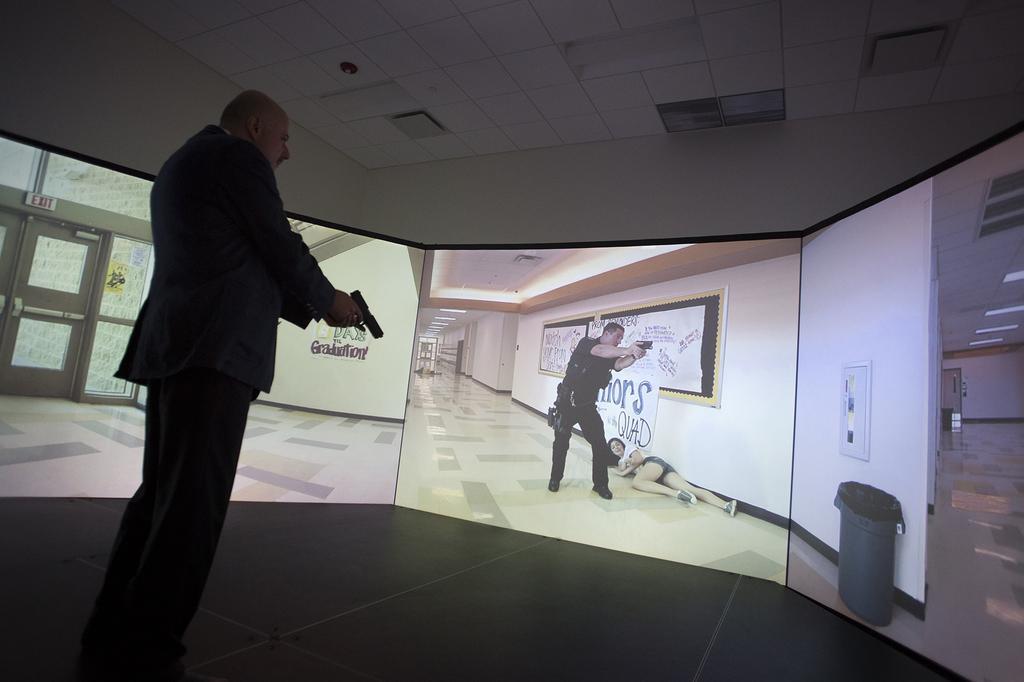Describe this image in one or two sentences. In the bottom left corner of the image a man is standing and holding a gun. In front of him we can see a screen. At the top of the image we can see wall and ceiling. 